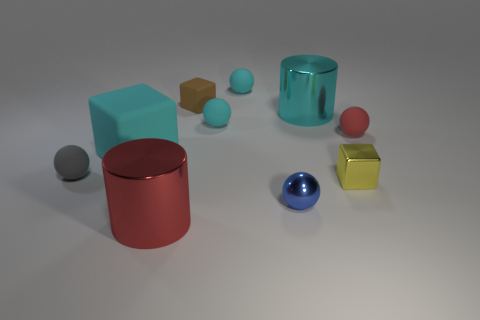Subtract all blue balls. How many balls are left? 4 Subtract all tiny gray spheres. How many spheres are left? 4 Subtract all purple cubes. Subtract all green cylinders. How many cubes are left? 3 Subtract all cylinders. How many objects are left? 8 Subtract all red balls. Subtract all red metallic objects. How many objects are left? 8 Add 7 large cubes. How many large cubes are left? 8 Add 1 red things. How many red things exist? 3 Subtract 0 yellow cylinders. How many objects are left? 10 